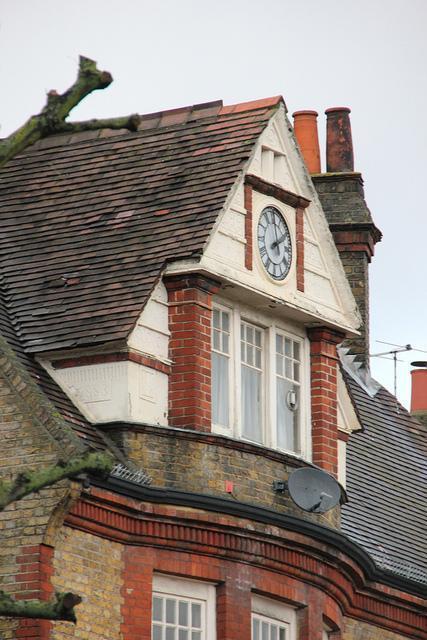How many zebras are on the road?
Give a very brief answer. 0. 